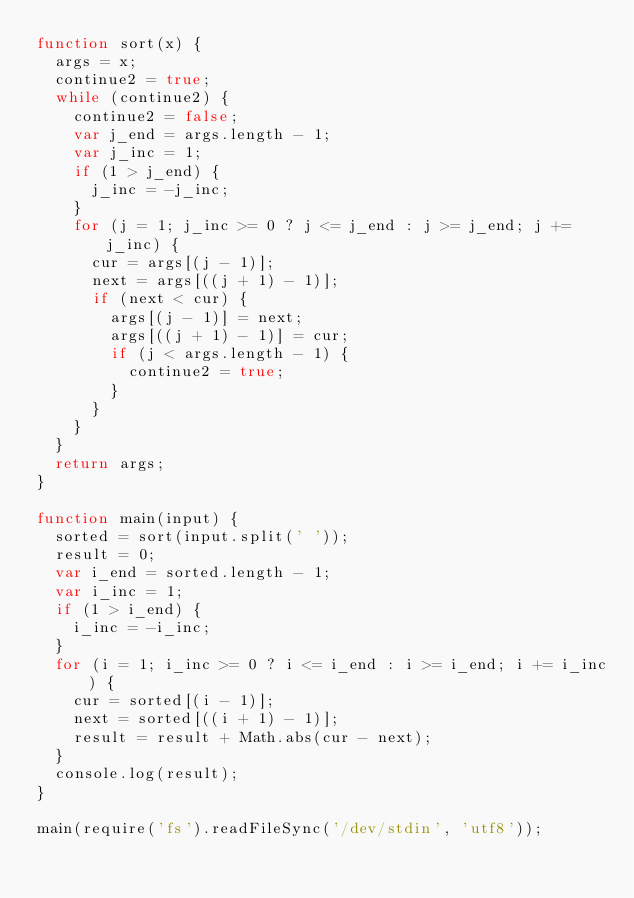<code> <loc_0><loc_0><loc_500><loc_500><_JavaScript_>function sort(x) {
  args = x;
  continue2 = true;
  while (continue2) {
    continue2 = false;
    var j_end = args.length - 1;
    var j_inc = 1;
    if (1 > j_end) {
      j_inc = -j_inc;
    }
    for (j = 1; j_inc >= 0 ? j <= j_end : j >= j_end; j += j_inc) {
      cur = args[(j - 1)];
      next = args[((j + 1) - 1)];
      if (next < cur) {
        args[(j - 1)] = next;
        args[((j + 1) - 1)] = cur;
        if (j < args.length - 1) {
          continue2 = true;
        }
      }
    }
  }
  return args;
}

function main(input) {
  sorted = sort(input.split(' '));
  result = 0;
  var i_end = sorted.length - 1;
  var i_inc = 1;
  if (1 > i_end) {
    i_inc = -i_inc;
  }
  for (i = 1; i_inc >= 0 ? i <= i_end : i >= i_end; i += i_inc) {
    cur = sorted[(i - 1)];
    next = sorted[((i + 1) - 1)];
    result = result + Math.abs(cur - next);
  }
  console.log(result);
}

main(require('fs').readFileSync('/dev/stdin', 'utf8'));</code> 